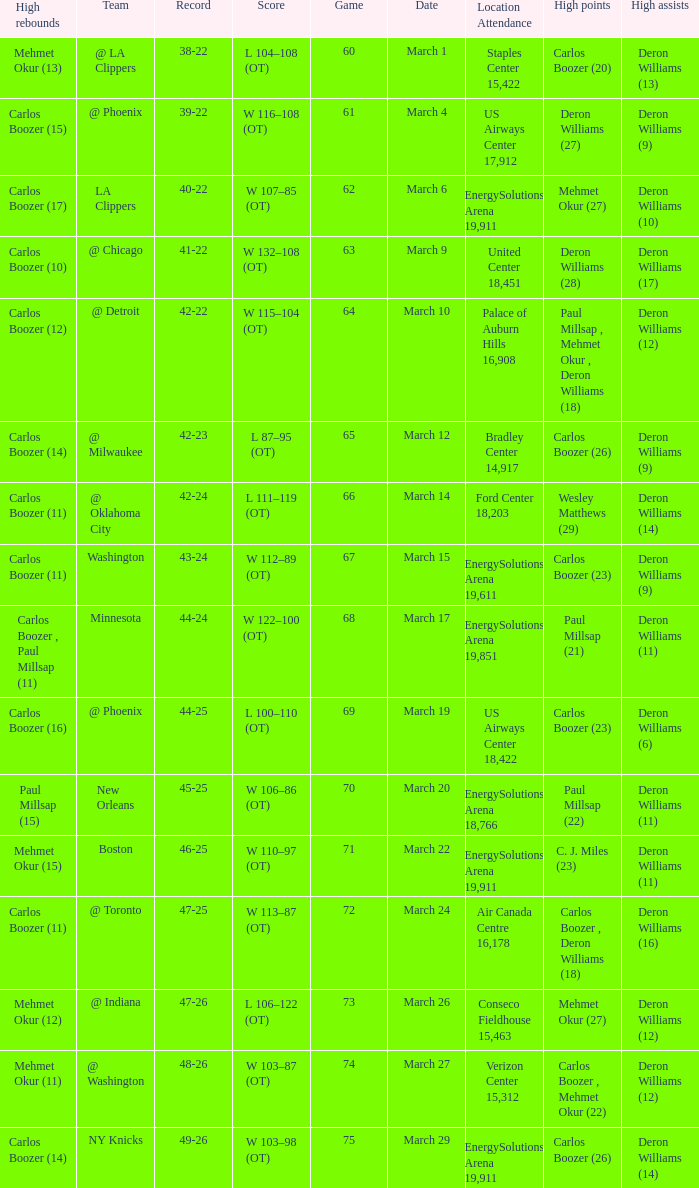How many different players did the most high assists on the March 4 game? 1.0. 